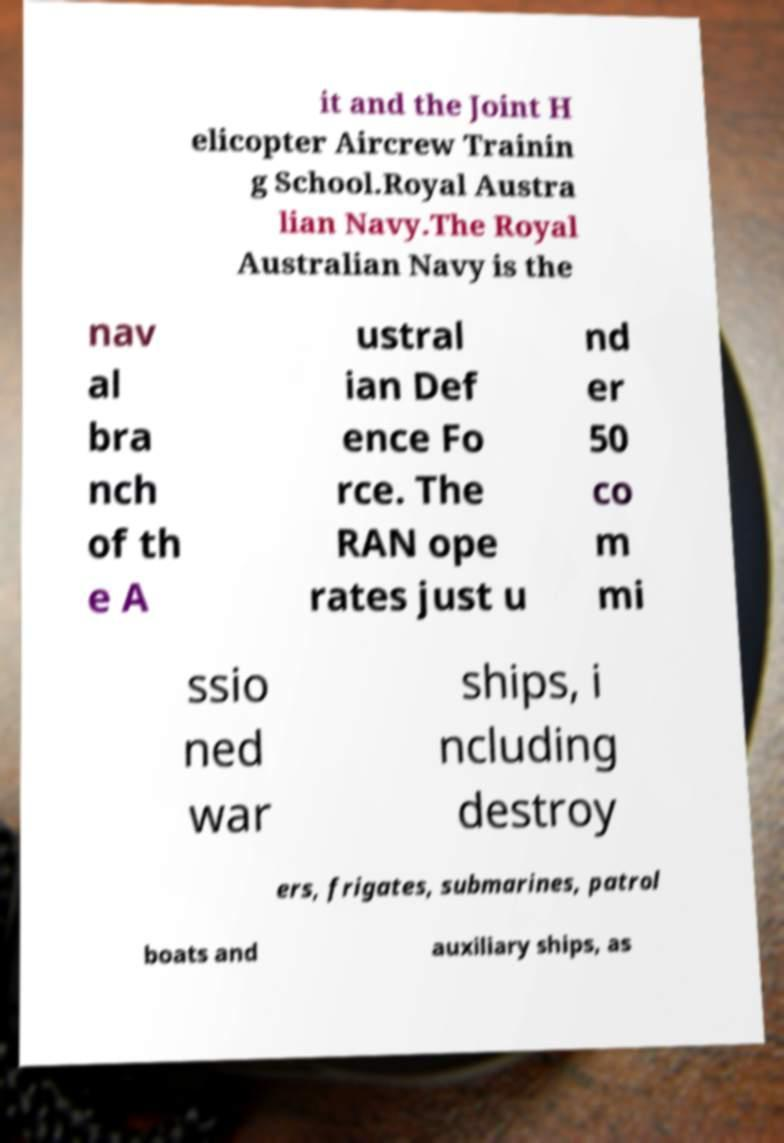Can you accurately transcribe the text from the provided image for me? it and the Joint H elicopter Aircrew Trainin g School.Royal Austra lian Navy.The Royal Australian Navy is the nav al bra nch of th e A ustral ian Def ence Fo rce. The RAN ope rates just u nd er 50 co m mi ssio ned war ships, i ncluding destroy ers, frigates, submarines, patrol boats and auxiliary ships, as 